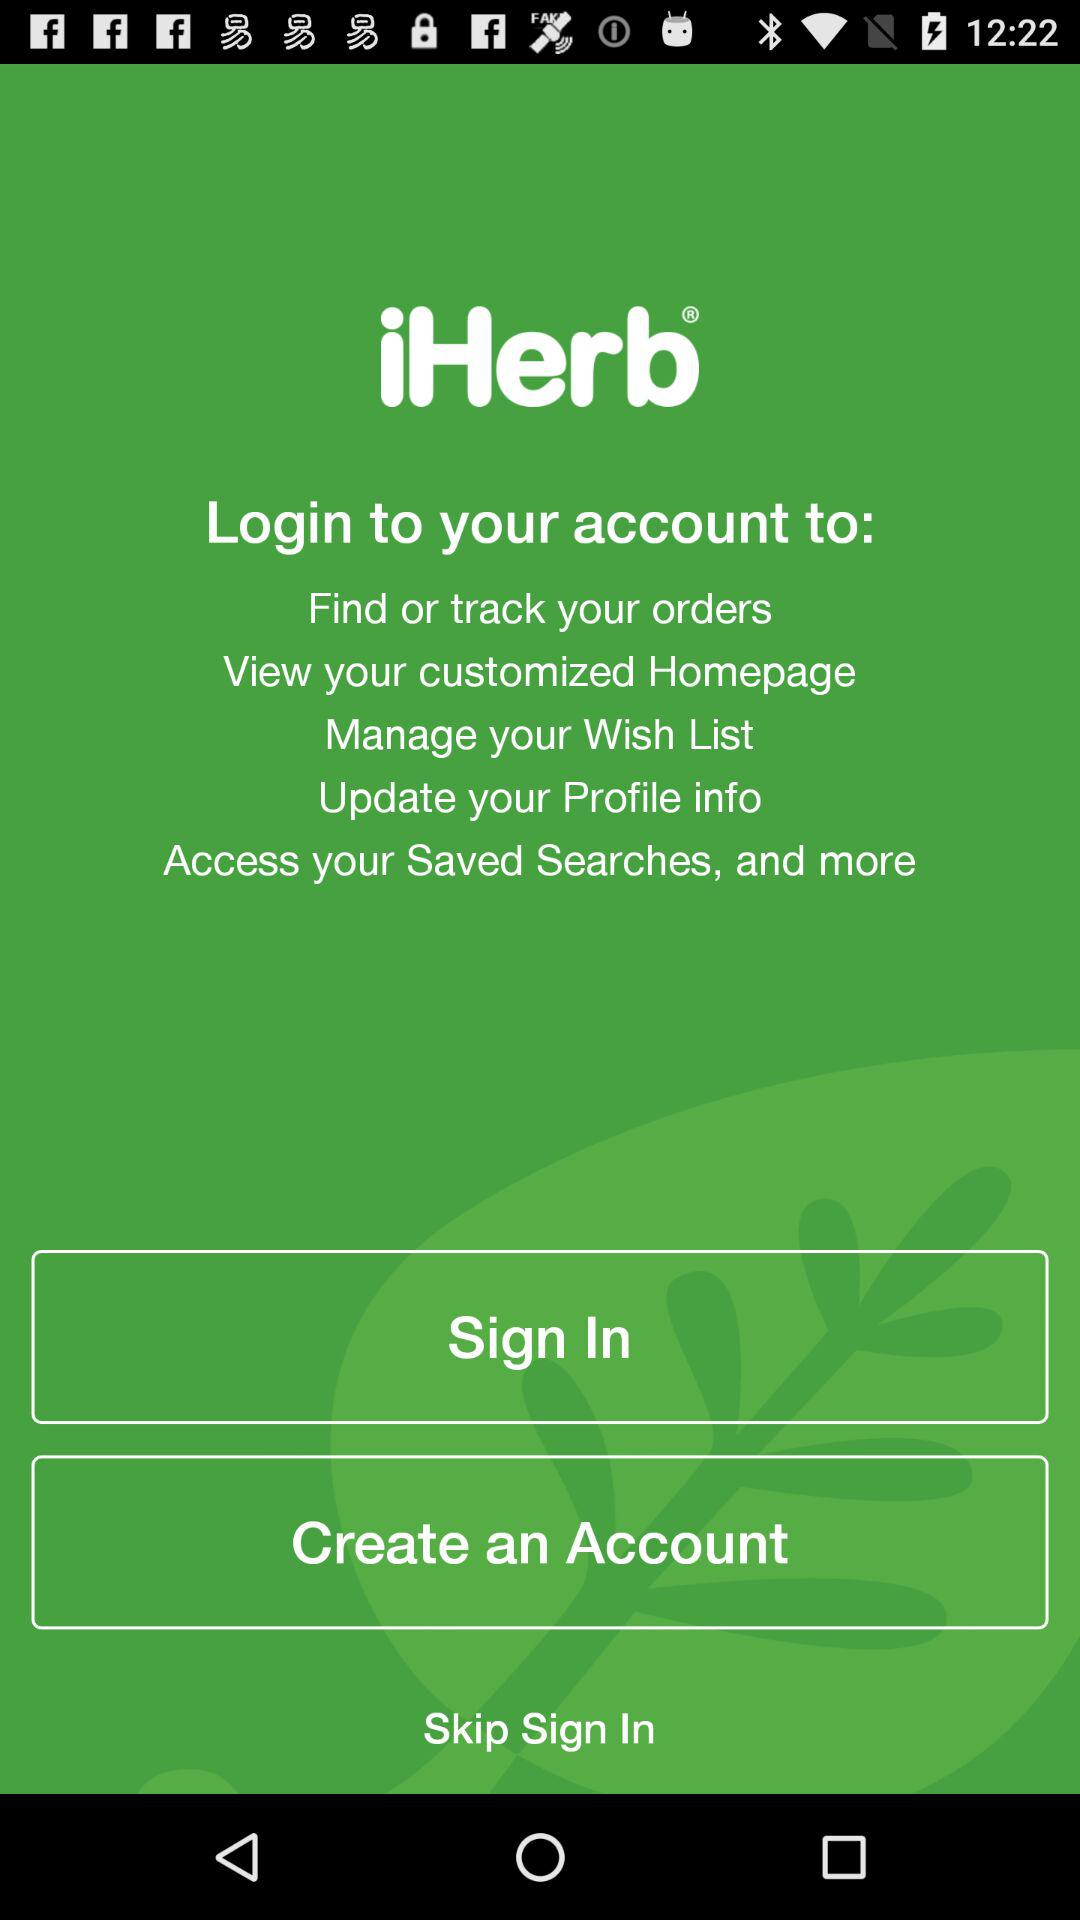Which types of personal information are required to create an account?
When the provided information is insufficient, respond with <no answer>. <no answer> 